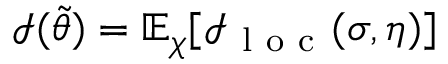Convert formula to latex. <formula><loc_0><loc_0><loc_500><loc_500>\mathcal { I } ( \tilde { \theta } ) = \mathbb { E } _ { \chi } [ \mathcal { I } _ { l o c } ( \sigma , \eta ) ]</formula> 